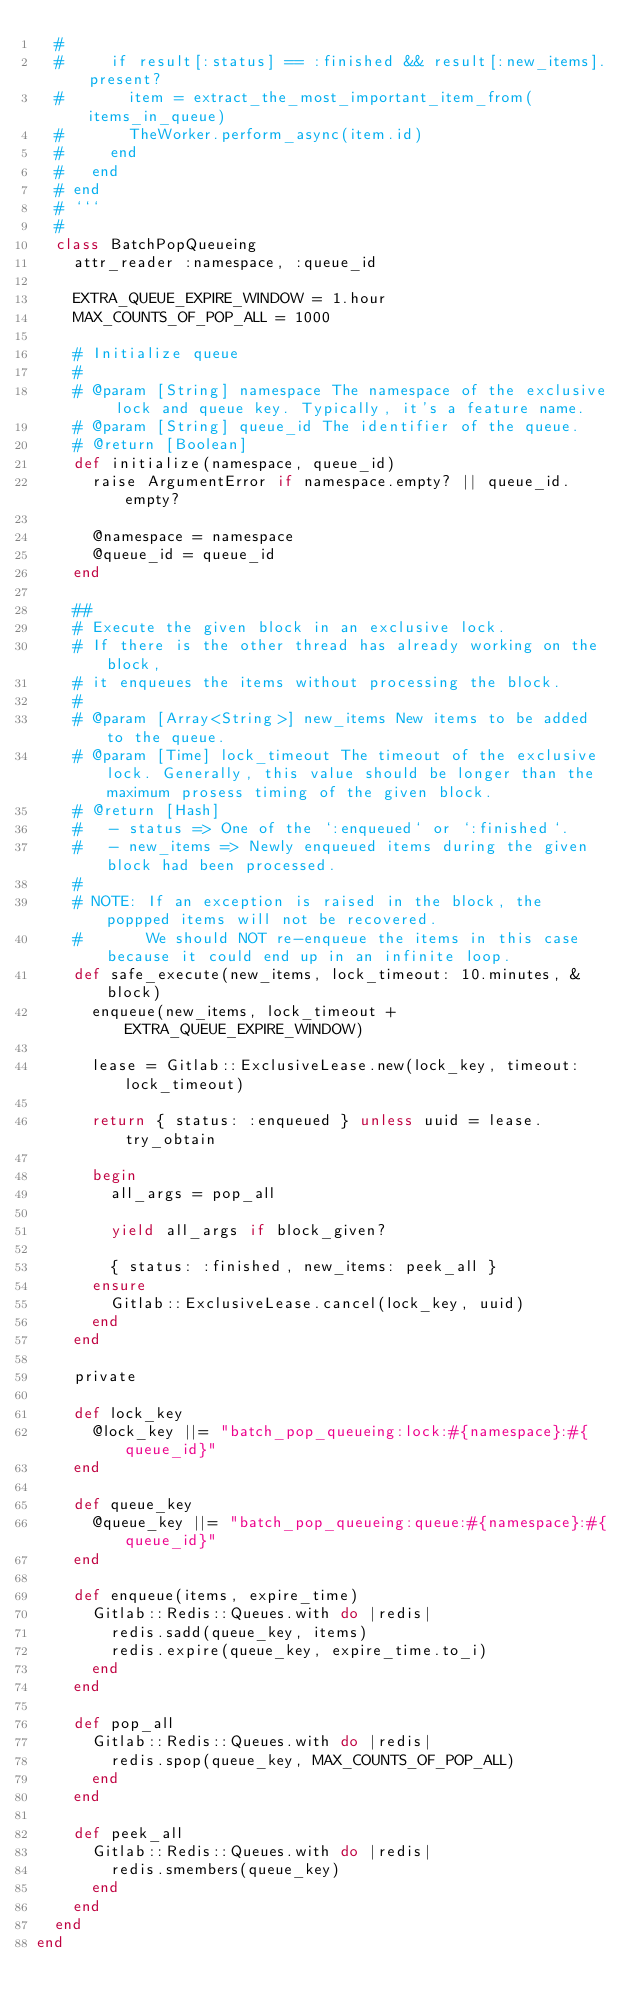<code> <loc_0><loc_0><loc_500><loc_500><_Ruby_>  #
  #     if result[:status] == :finished && result[:new_items].present?
  #       item = extract_the_most_important_item_from(items_in_queue)
  #       TheWorker.perform_async(item.id)
  #     end
  #   end
  # end
  # ```
  #
  class BatchPopQueueing
    attr_reader :namespace, :queue_id

    EXTRA_QUEUE_EXPIRE_WINDOW = 1.hour
    MAX_COUNTS_OF_POP_ALL = 1000

    # Initialize queue
    #
    # @param [String] namespace The namespace of the exclusive lock and queue key. Typically, it's a feature name.
    # @param [String] queue_id The identifier of the queue.
    # @return [Boolean]
    def initialize(namespace, queue_id)
      raise ArgumentError if namespace.empty? || queue_id.empty?

      @namespace = namespace
      @queue_id = queue_id
    end

    ##
    # Execute the given block in an exclusive lock.
    # If there is the other thread has already working on the block,
    # it enqueues the items without processing the block.
    #
    # @param [Array<String>] new_items New items to be added to the queue.
    # @param [Time] lock_timeout The timeout of the exclusive lock. Generally, this value should be longer than the maximum prosess timing of the given block.
    # @return [Hash]
    #   - status => One of the `:enqueued` or `:finished`.
    #   - new_items => Newly enqueued items during the given block had been processed.
    #
    # NOTE: If an exception is raised in the block, the poppped items will not be recovered.
    #       We should NOT re-enqueue the items in this case because it could end up in an infinite loop.
    def safe_execute(new_items, lock_timeout: 10.minutes, &block)
      enqueue(new_items, lock_timeout + EXTRA_QUEUE_EXPIRE_WINDOW)

      lease = Gitlab::ExclusiveLease.new(lock_key, timeout: lock_timeout)

      return { status: :enqueued } unless uuid = lease.try_obtain

      begin
        all_args = pop_all

        yield all_args if block_given?

        { status: :finished, new_items: peek_all }
      ensure
        Gitlab::ExclusiveLease.cancel(lock_key, uuid)
      end
    end

    private

    def lock_key
      @lock_key ||= "batch_pop_queueing:lock:#{namespace}:#{queue_id}"
    end

    def queue_key
      @queue_key ||= "batch_pop_queueing:queue:#{namespace}:#{queue_id}"
    end

    def enqueue(items, expire_time)
      Gitlab::Redis::Queues.with do |redis|
        redis.sadd(queue_key, items)
        redis.expire(queue_key, expire_time.to_i)
      end
    end

    def pop_all
      Gitlab::Redis::Queues.with do |redis|
        redis.spop(queue_key, MAX_COUNTS_OF_POP_ALL)
      end
    end

    def peek_all
      Gitlab::Redis::Queues.with do |redis|
        redis.smembers(queue_key)
      end
    end
  end
end
</code> 